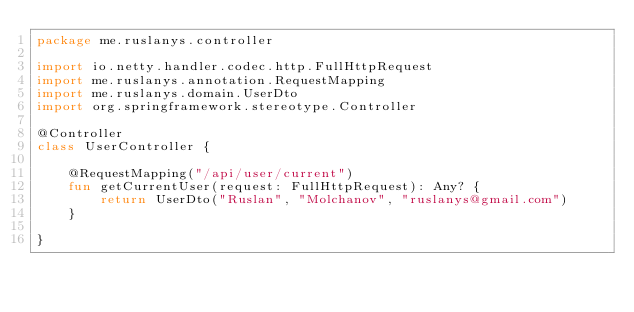<code> <loc_0><loc_0><loc_500><loc_500><_Kotlin_>package me.ruslanys.controller

import io.netty.handler.codec.http.FullHttpRequest
import me.ruslanys.annotation.RequestMapping
import me.ruslanys.domain.UserDto
import org.springframework.stereotype.Controller

@Controller
class UserController {

    @RequestMapping("/api/user/current")
    fun getCurrentUser(request: FullHttpRequest): Any? {
        return UserDto("Ruslan", "Molchanov", "ruslanys@gmail.com")
    }

}</code> 